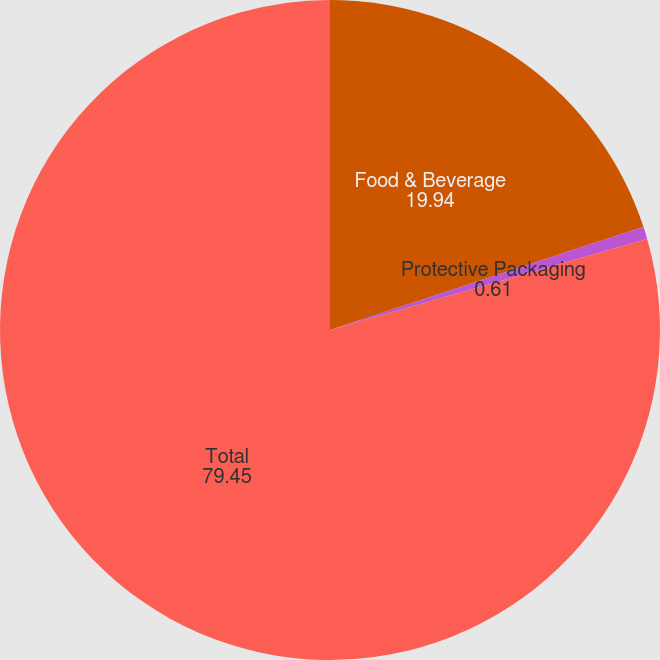Convert chart. <chart><loc_0><loc_0><loc_500><loc_500><pie_chart><fcel>Food & Beverage<fcel>Protective Packaging<fcel>Total<nl><fcel>19.94%<fcel>0.61%<fcel>79.45%<nl></chart> 